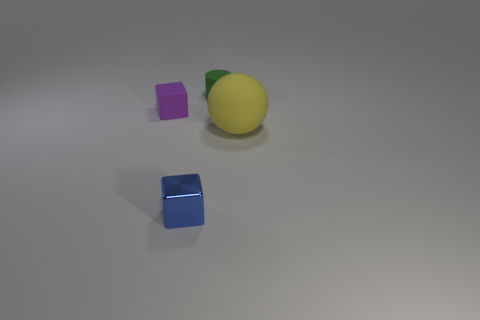Can you tell me about the shapes and colors visible in the image? In the image, there are three distinct objects, all demonstrating different shapes and colors. Specifically, we have a purple cube, a shiny yellow spherical object that resembles a lemon, and a blue cube with a notably reflective surface. The stark contrast between their shapes and the uniform, nondescript background highlights their geometric differences. 